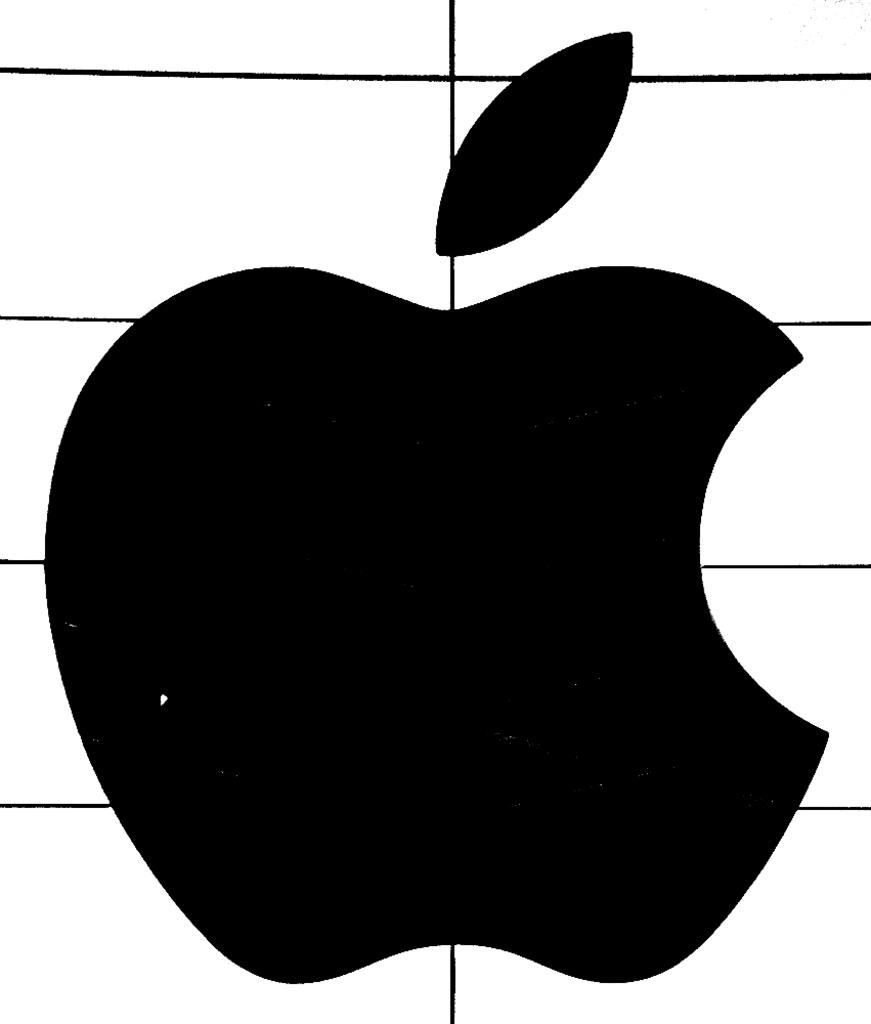What is the main feature of the image? There is a logo in the image. What color is the background of the image? The background of the image is white. How many ladybugs can be seen sleeping in the image? There are no ladybugs or any indication of sleep in the image; it features a logo on a white background. 